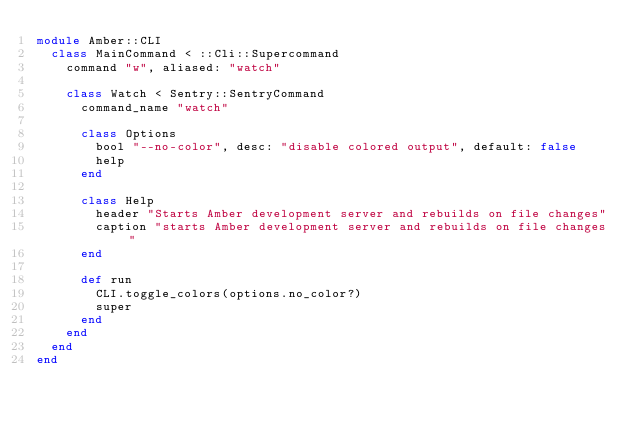Convert code to text. <code><loc_0><loc_0><loc_500><loc_500><_Crystal_>module Amber::CLI
  class MainCommand < ::Cli::Supercommand
    command "w", aliased: "watch"

    class Watch < Sentry::SentryCommand
      command_name "watch"

      class Options
        bool "--no-color", desc: "disable colored output", default: false
        help
      end

      class Help
        header "Starts Amber development server and rebuilds on file changes"
        caption "starts Amber development server and rebuilds on file changes"
      end

      def run
        CLI.toggle_colors(options.no_color?)
        super
      end
    end
  end
end
</code> 